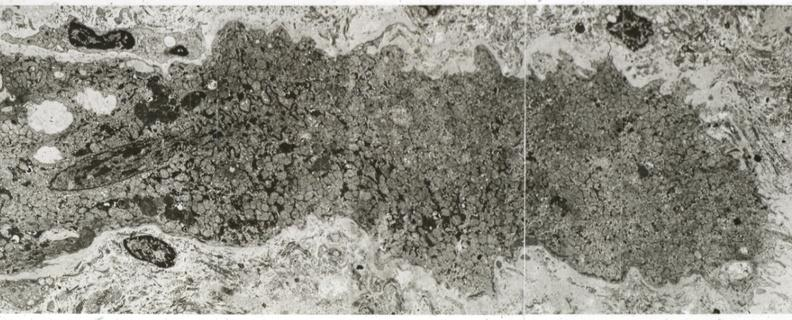what is present?
Answer the question using a single word or phrase. Cardiovascular 